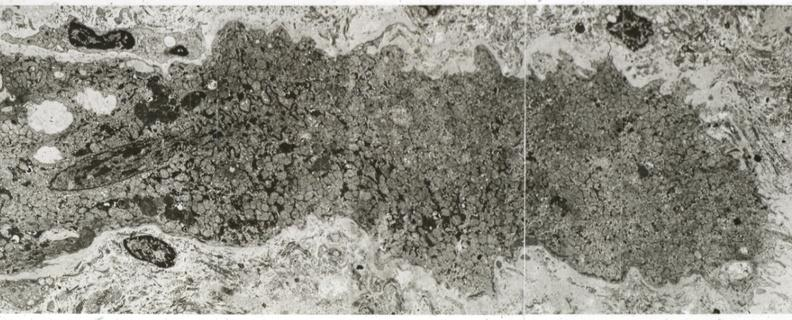what is present?
Answer the question using a single word or phrase. Cardiovascular 